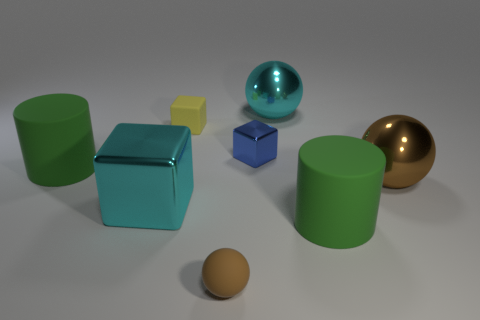Add 1 large cyan matte objects. How many objects exist? 9 Add 1 cyan metallic spheres. How many cyan metallic spheres are left? 2 Add 3 small red cylinders. How many small red cylinders exist? 3 Subtract all brown balls. How many balls are left? 1 Subtract all small blocks. How many blocks are left? 1 Subtract 0 purple balls. How many objects are left? 8 Subtract all balls. How many objects are left? 5 Subtract 1 balls. How many balls are left? 2 Subtract all brown balls. Subtract all blue cubes. How many balls are left? 1 Subtract all green balls. How many yellow cubes are left? 1 